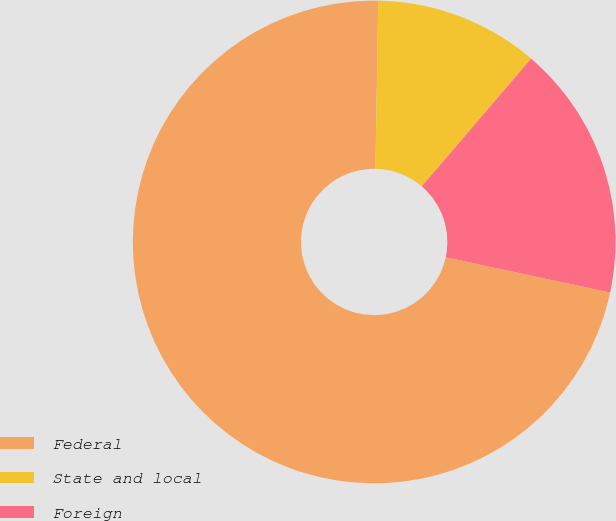Convert chart. <chart><loc_0><loc_0><loc_500><loc_500><pie_chart><fcel>Federal<fcel>State and local<fcel>Foreign<nl><fcel>71.91%<fcel>11.0%<fcel>17.09%<nl></chart> 